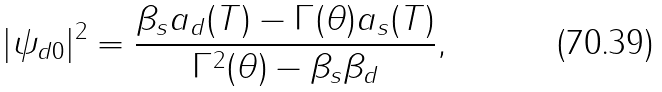Convert formula to latex. <formula><loc_0><loc_0><loc_500><loc_500>| \psi _ { d 0 } | ^ { 2 } = \frac { \beta _ { s } a _ { d } ( T ) - \Gamma ( \theta ) a _ { s } ( T ) } { \Gamma ^ { 2 } ( \theta ) - \beta _ { s } \beta _ { d } } ,</formula> 